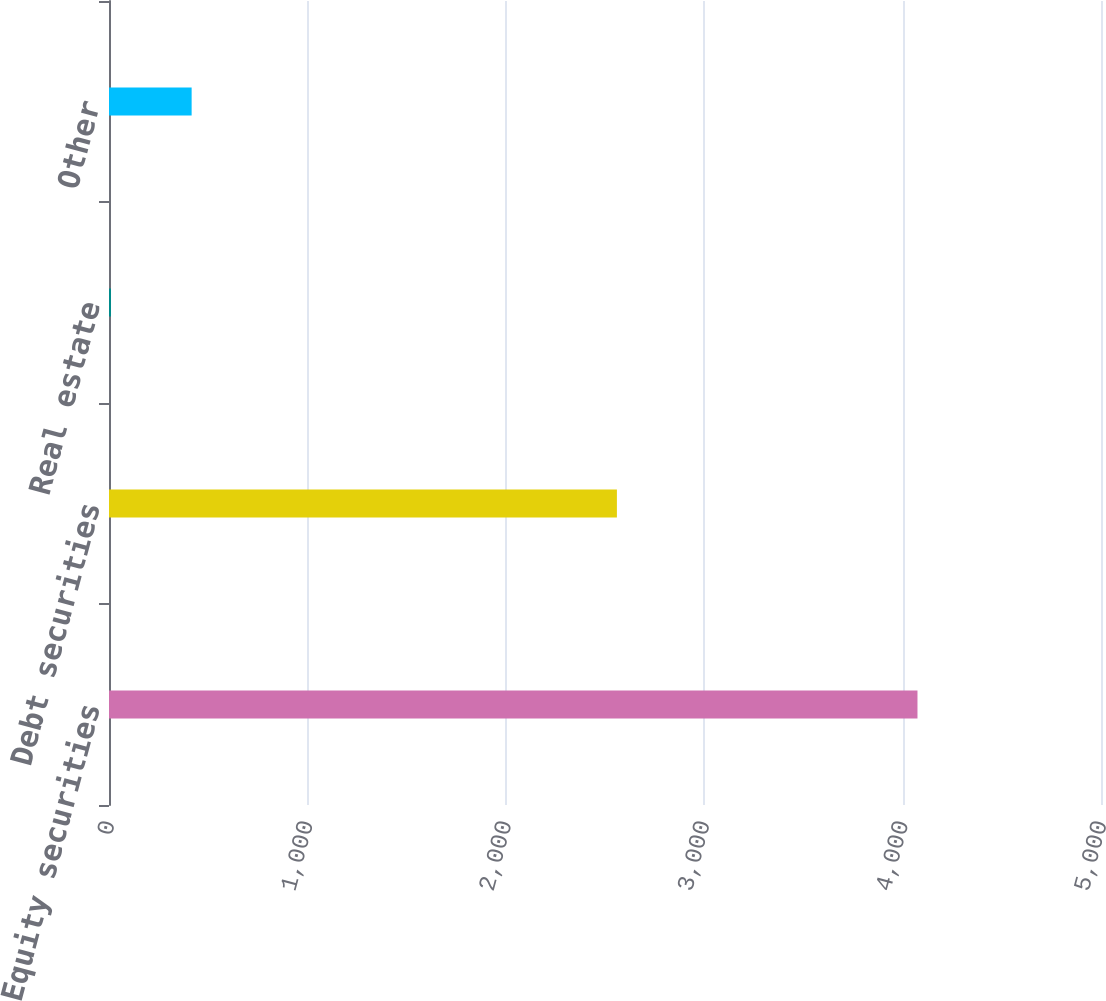<chart> <loc_0><loc_0><loc_500><loc_500><bar_chart><fcel>Equity securities<fcel>Debt securities<fcel>Real estate<fcel>Other<nl><fcel>4075<fcel>2560<fcel>10<fcel>416.5<nl></chart> 